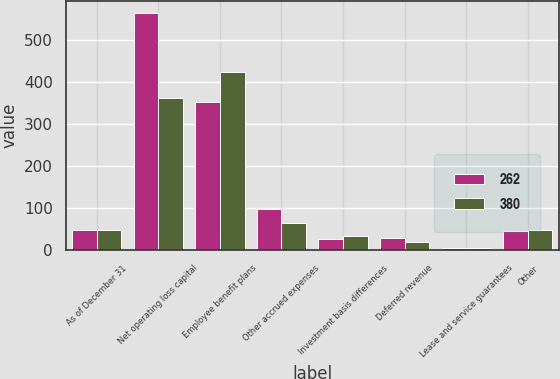Convert chart. <chart><loc_0><loc_0><loc_500><loc_500><stacked_bar_chart><ecel><fcel>As of December 31<fcel>Net operating loss capital<fcel>Employee benefit plans<fcel>Other accrued expenses<fcel>Investment basis differences<fcel>Deferred revenue<fcel>Lease and service guarantees<fcel>Other<nl><fcel>262<fcel>47.5<fcel>563<fcel>351<fcel>98<fcel>28<fcel>29<fcel>5<fcel>46<nl><fcel>380<fcel>47.5<fcel>362<fcel>424<fcel>65<fcel>35<fcel>20<fcel>6<fcel>49<nl></chart> 